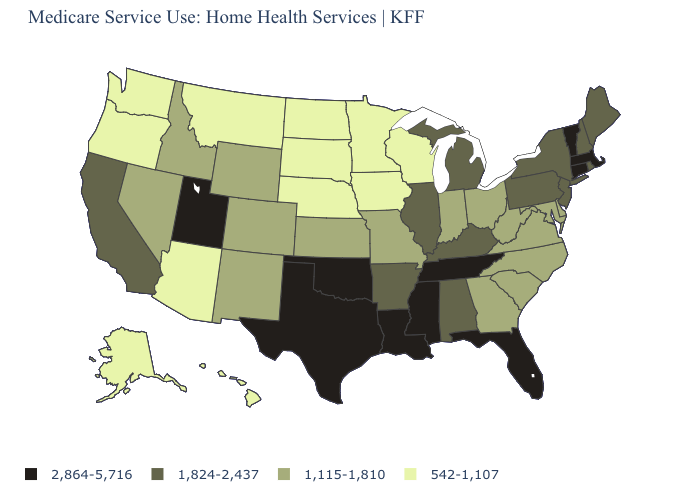What is the lowest value in states that border Pennsylvania?
Be succinct. 1,115-1,810. Does Pennsylvania have the same value as Michigan?
Give a very brief answer. Yes. What is the value of Pennsylvania?
Short answer required. 1,824-2,437. What is the value of Iowa?
Answer briefly. 542-1,107. What is the value of Alabama?
Give a very brief answer. 1,824-2,437. What is the value of Michigan?
Keep it brief. 1,824-2,437. Which states have the lowest value in the West?
Be succinct. Alaska, Arizona, Hawaii, Montana, Oregon, Washington. Name the states that have a value in the range 1,115-1,810?
Keep it brief. Colorado, Delaware, Georgia, Idaho, Indiana, Kansas, Maryland, Missouri, Nevada, New Mexico, North Carolina, Ohio, South Carolina, Virginia, West Virginia, Wyoming. What is the lowest value in the MidWest?
Write a very short answer. 542-1,107. Which states hav the highest value in the MidWest?
Be succinct. Illinois, Michigan. Name the states that have a value in the range 2,864-5,716?
Short answer required. Connecticut, Florida, Louisiana, Massachusetts, Mississippi, Oklahoma, Tennessee, Texas, Utah, Vermont. Is the legend a continuous bar?
Give a very brief answer. No. Name the states that have a value in the range 1,824-2,437?
Give a very brief answer. Alabama, Arkansas, California, Illinois, Kentucky, Maine, Michigan, New Hampshire, New Jersey, New York, Pennsylvania, Rhode Island. What is the value of Kansas?
Write a very short answer. 1,115-1,810. What is the highest value in states that border Illinois?
Keep it brief. 1,824-2,437. 